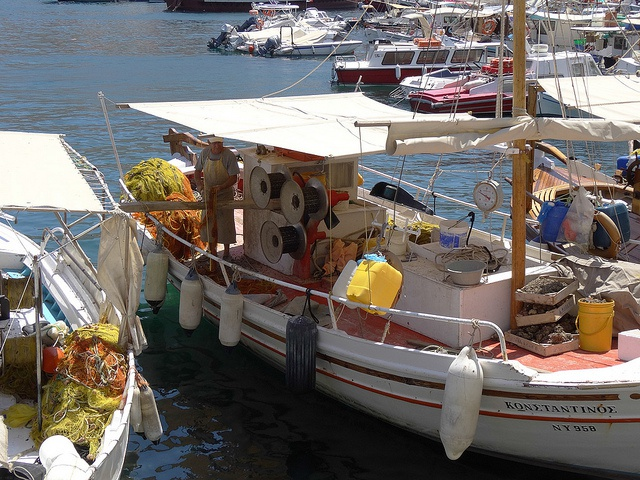Describe the objects in this image and their specific colors. I can see boat in gray, white, black, and darkgray tones, boat in gray, white, darkgray, and olive tones, people in gray, maroon, and black tones, boat in gray, white, navy, and darkgray tones, and clock in gray tones in this image. 